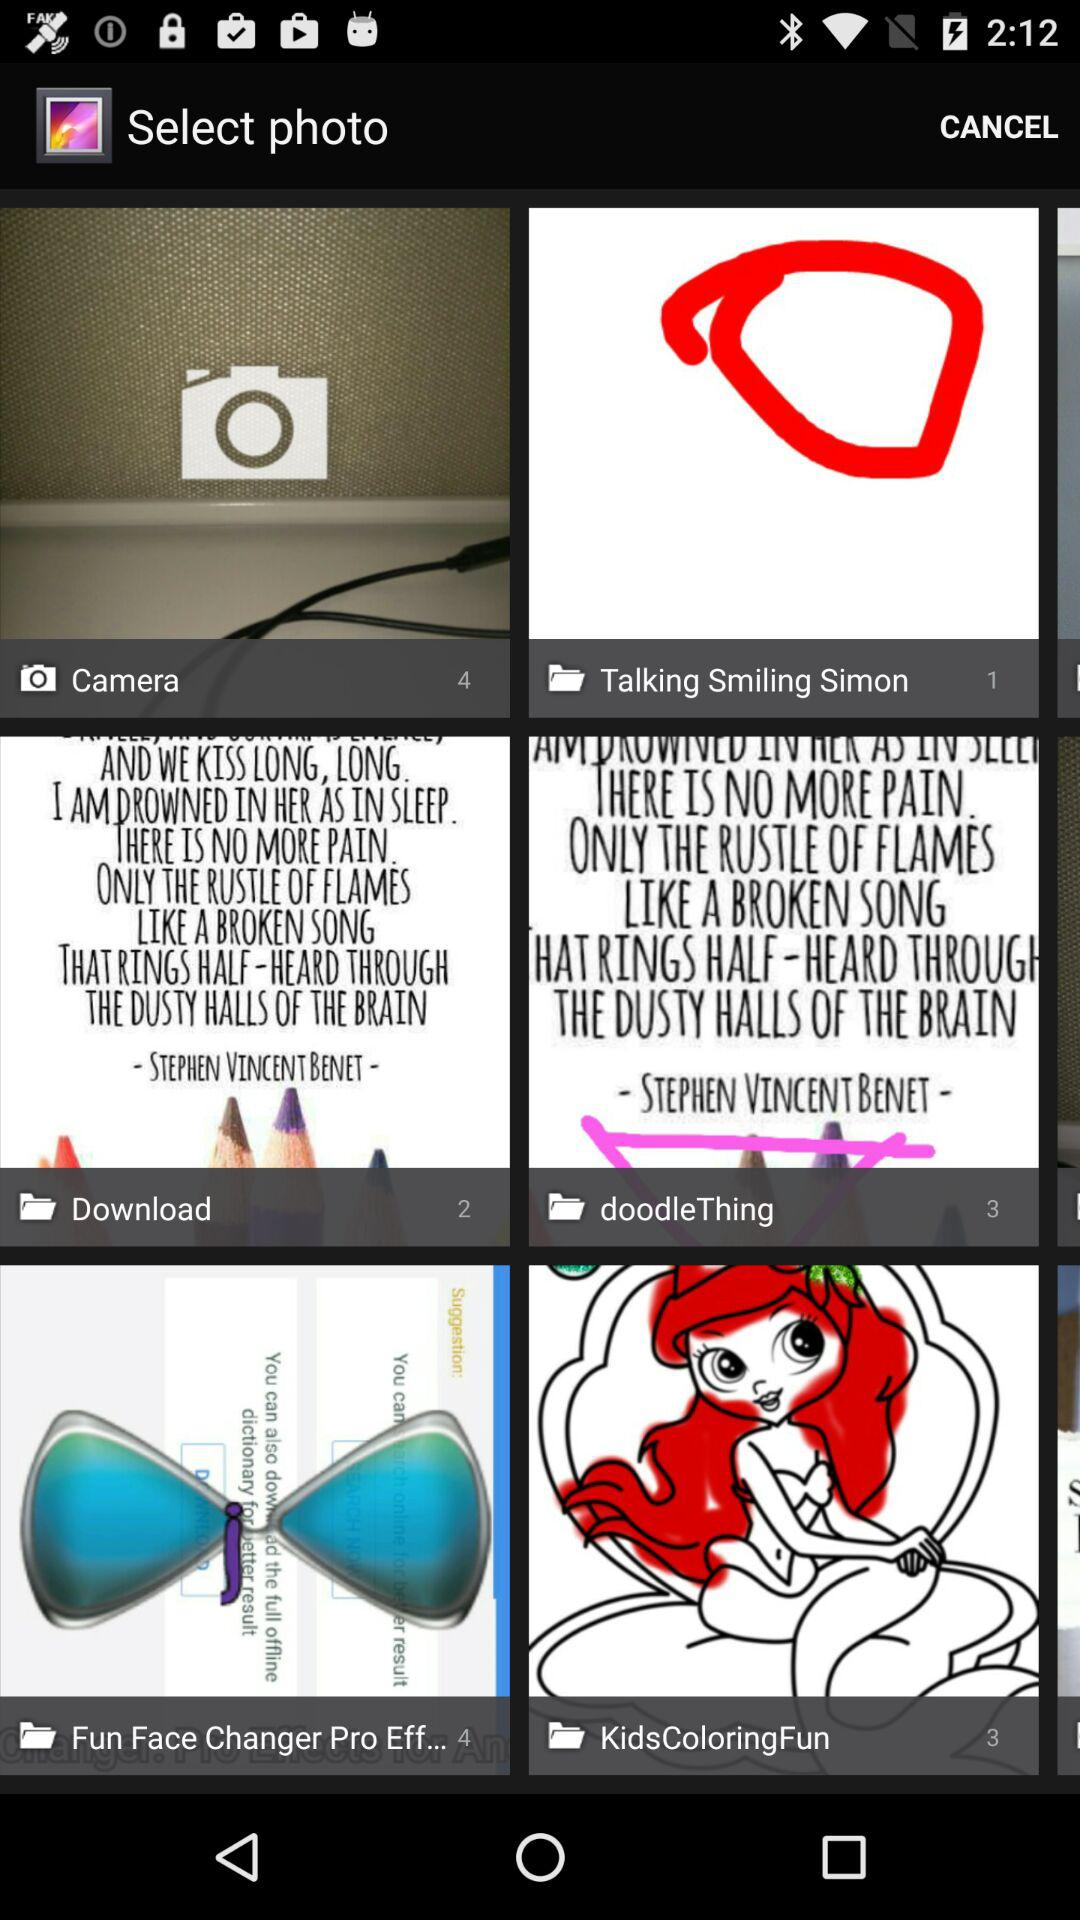What's the number of images stored in the "Download" folder? The number of images is 2. 